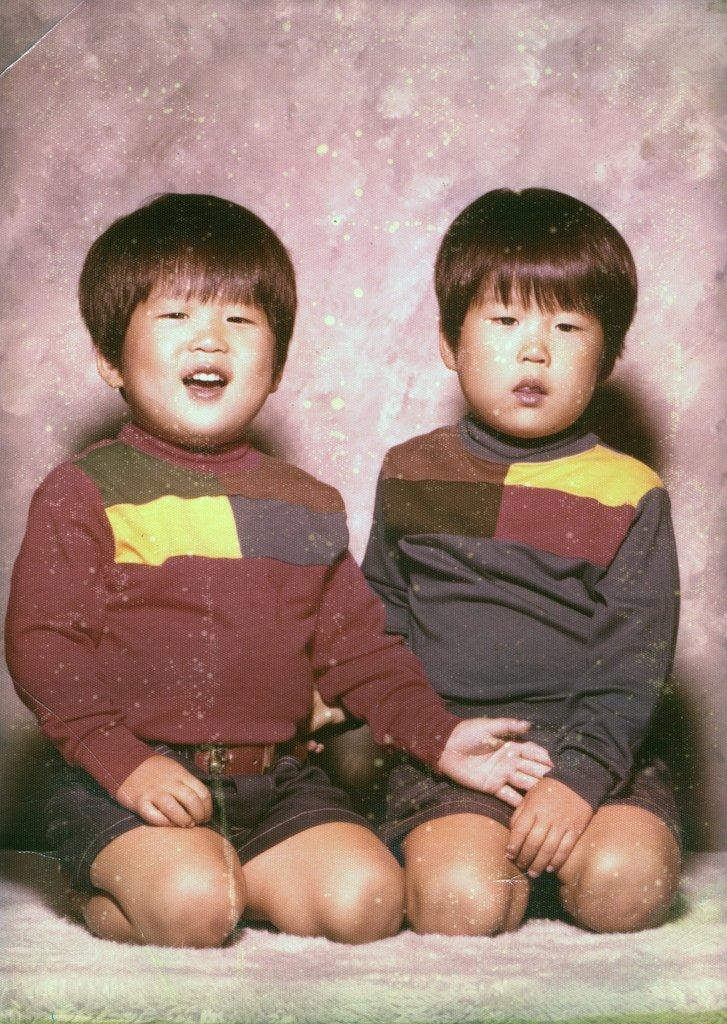How many people are in the image? There are two boys in the image. What are the boys doing in the image? The boys are sitting on a carpet. What can be seen in the background of the image? There is a wall in the background of the image. What type of cars can be seen in the image? There are no cars present in the image. What trade is being conducted in the image? There is no trade being conducted in the image. Is it raining in the image? There is no indication of rain in the image. 